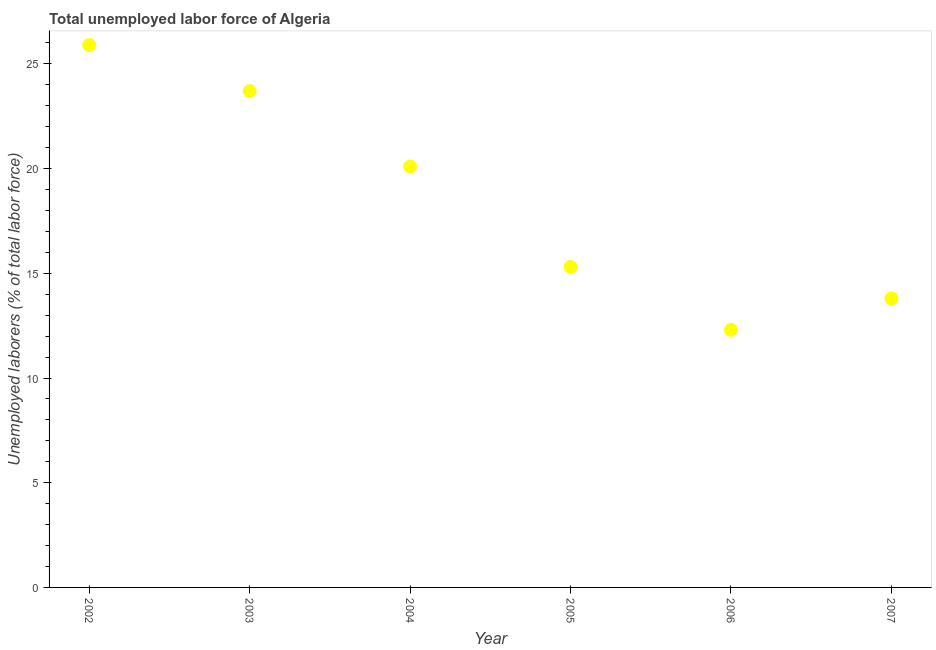What is the total unemployed labour force in 2002?
Provide a succinct answer. 25.9. Across all years, what is the maximum total unemployed labour force?
Your response must be concise. 25.9. Across all years, what is the minimum total unemployed labour force?
Provide a short and direct response. 12.3. In which year was the total unemployed labour force maximum?
Provide a short and direct response. 2002. What is the sum of the total unemployed labour force?
Provide a succinct answer. 111.1. What is the difference between the total unemployed labour force in 2003 and 2007?
Ensure brevity in your answer.  9.9. What is the average total unemployed labour force per year?
Offer a very short reply. 18.52. What is the median total unemployed labour force?
Make the answer very short. 17.7. What is the ratio of the total unemployed labour force in 2005 to that in 2007?
Make the answer very short. 1.11. What is the difference between the highest and the second highest total unemployed labour force?
Offer a very short reply. 2.2. Is the sum of the total unemployed labour force in 2002 and 2005 greater than the maximum total unemployed labour force across all years?
Give a very brief answer. Yes. What is the difference between the highest and the lowest total unemployed labour force?
Ensure brevity in your answer.  13.6. Does the total unemployed labour force monotonically increase over the years?
Your answer should be compact. No. How many years are there in the graph?
Keep it short and to the point. 6. What is the difference between two consecutive major ticks on the Y-axis?
Offer a terse response. 5. Does the graph contain any zero values?
Provide a short and direct response. No. What is the title of the graph?
Ensure brevity in your answer.  Total unemployed labor force of Algeria. What is the label or title of the Y-axis?
Offer a very short reply. Unemployed laborers (% of total labor force). What is the Unemployed laborers (% of total labor force) in 2002?
Offer a very short reply. 25.9. What is the Unemployed laborers (% of total labor force) in 2003?
Offer a very short reply. 23.7. What is the Unemployed laborers (% of total labor force) in 2004?
Keep it short and to the point. 20.1. What is the Unemployed laborers (% of total labor force) in 2005?
Provide a succinct answer. 15.3. What is the Unemployed laborers (% of total labor force) in 2006?
Make the answer very short. 12.3. What is the Unemployed laborers (% of total labor force) in 2007?
Your response must be concise. 13.8. What is the difference between the Unemployed laborers (% of total labor force) in 2002 and 2003?
Your answer should be very brief. 2.2. What is the difference between the Unemployed laborers (% of total labor force) in 2002 and 2004?
Offer a terse response. 5.8. What is the difference between the Unemployed laborers (% of total labor force) in 2002 and 2005?
Keep it short and to the point. 10.6. What is the difference between the Unemployed laborers (% of total labor force) in 2003 and 2004?
Offer a terse response. 3.6. What is the difference between the Unemployed laborers (% of total labor force) in 2003 and 2006?
Make the answer very short. 11.4. What is the difference between the Unemployed laborers (% of total labor force) in 2004 and 2005?
Offer a very short reply. 4.8. What is the difference between the Unemployed laborers (% of total labor force) in 2004 and 2007?
Ensure brevity in your answer.  6.3. What is the difference between the Unemployed laborers (% of total labor force) in 2005 and 2007?
Your response must be concise. 1.5. What is the difference between the Unemployed laborers (% of total labor force) in 2006 and 2007?
Make the answer very short. -1.5. What is the ratio of the Unemployed laborers (% of total labor force) in 2002 to that in 2003?
Offer a very short reply. 1.09. What is the ratio of the Unemployed laborers (% of total labor force) in 2002 to that in 2004?
Give a very brief answer. 1.29. What is the ratio of the Unemployed laborers (% of total labor force) in 2002 to that in 2005?
Offer a terse response. 1.69. What is the ratio of the Unemployed laborers (% of total labor force) in 2002 to that in 2006?
Keep it short and to the point. 2.11. What is the ratio of the Unemployed laborers (% of total labor force) in 2002 to that in 2007?
Make the answer very short. 1.88. What is the ratio of the Unemployed laborers (% of total labor force) in 2003 to that in 2004?
Offer a very short reply. 1.18. What is the ratio of the Unemployed laborers (% of total labor force) in 2003 to that in 2005?
Your answer should be compact. 1.55. What is the ratio of the Unemployed laborers (% of total labor force) in 2003 to that in 2006?
Offer a terse response. 1.93. What is the ratio of the Unemployed laborers (% of total labor force) in 2003 to that in 2007?
Your answer should be very brief. 1.72. What is the ratio of the Unemployed laborers (% of total labor force) in 2004 to that in 2005?
Provide a short and direct response. 1.31. What is the ratio of the Unemployed laborers (% of total labor force) in 2004 to that in 2006?
Your response must be concise. 1.63. What is the ratio of the Unemployed laborers (% of total labor force) in 2004 to that in 2007?
Give a very brief answer. 1.46. What is the ratio of the Unemployed laborers (% of total labor force) in 2005 to that in 2006?
Give a very brief answer. 1.24. What is the ratio of the Unemployed laborers (% of total labor force) in 2005 to that in 2007?
Keep it short and to the point. 1.11. What is the ratio of the Unemployed laborers (% of total labor force) in 2006 to that in 2007?
Give a very brief answer. 0.89. 